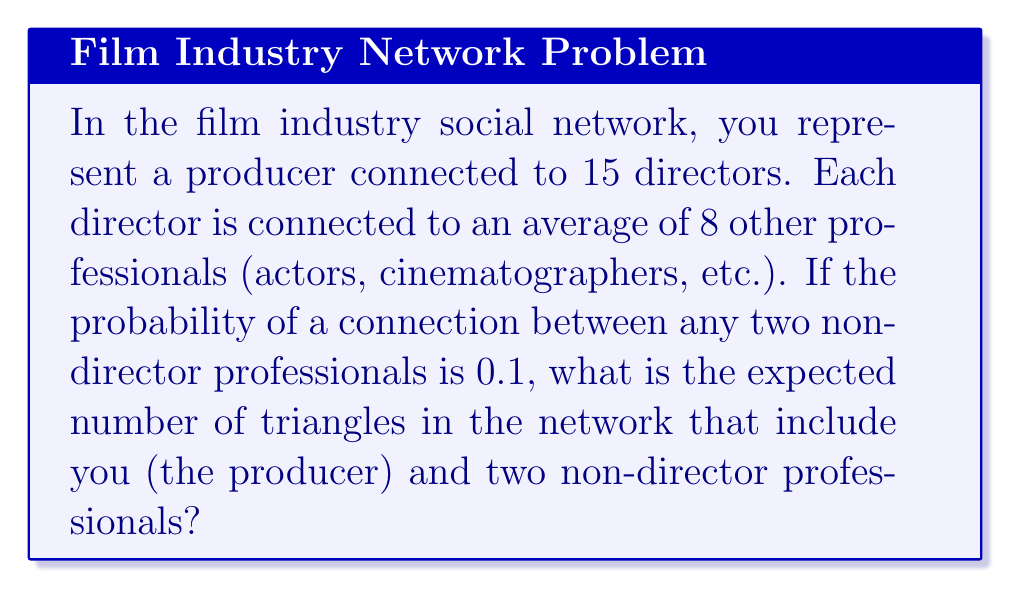Help me with this question. To solve this problem, we need to use concepts from graph theory and probability. Let's break it down step-by-step:

1) First, we need to understand the structure of the network:
   - You (the producer) are connected to 15 directors
   - Each director is connected to an average of 8 other professionals
   - The probability of a connection between any two non-director professionals is 0.1

2) To form a triangle that includes you and two non-director professionals, we need:
   - Two professionals connected to the same director
   - These two professionals to be connected to each other

3) Let's calculate the number of pairs of professionals connected to each director:
   $${8 \choose 2} = \frac{8!}{2!(8-2)!} = 28$$

4) The total number of pairs across all 15 directors:
   $$15 \times 28 = 420$$

5) The probability of a connection between any two of these professionals is 0.1

6) Therefore, the expected number of triangles is:
   $$420 \times 0.1 = 42$$

This is because each pair has a 0.1 probability of being connected, and there are 420 pairs in total. The expected value is the sum of all possible outcomes multiplied by their probabilities.

In this case, we can think of it as having 420 independent Bernoulli trials (coin flips) with a probability of success (forming a triangle) of 0.1 each. The expected number of successes in such a scenario is simply the number of trials multiplied by the probability of success.
Answer: 42 triangles 